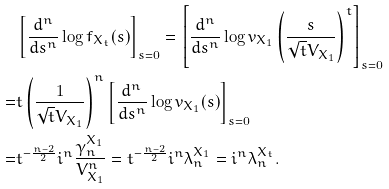Convert formula to latex. <formula><loc_0><loc_0><loc_500><loc_500>& \left [ \frac { d ^ { n } } { d s ^ { n } } \log f _ { X _ { t } } ( s ) \right ] _ { s = 0 } = \left [ \frac { d ^ { n } } { d s ^ { n } } \log v _ { X _ { 1 } } \left ( \frac { s } { \sqrt { t } V _ { X _ { 1 } } } \right ) ^ { t } \right ] _ { s = 0 } \\ = & t \left ( \frac { 1 } { \sqrt { t } V _ { X _ { 1 } } } \right ) ^ { n } \left [ \frac { d ^ { n } } { d s ^ { n } } \log v _ { X _ { 1 } } ( s ) \right ] _ { s = 0 } \\ = & t ^ { - \frac { n - 2 } { 2 } } i ^ { n } \frac { \gamma _ { n } ^ { X _ { 1 } } } { V _ { X _ { 1 } } ^ { n } } = t ^ { - \frac { n - 2 } { 2 } } i ^ { n } \lambda _ { n } ^ { X _ { 1 } } = i ^ { n } \lambda _ { n } ^ { X _ { t } } .</formula> 